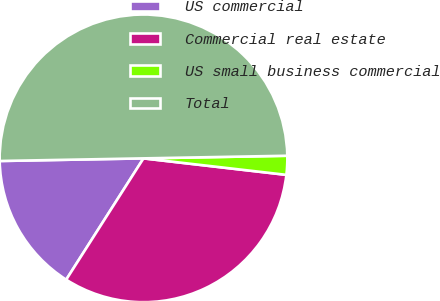<chart> <loc_0><loc_0><loc_500><loc_500><pie_chart><fcel>US commercial<fcel>Commercial real estate<fcel>US small business commercial<fcel>Total<nl><fcel>15.68%<fcel>32.2%<fcel>2.12%<fcel>50.0%<nl></chart> 